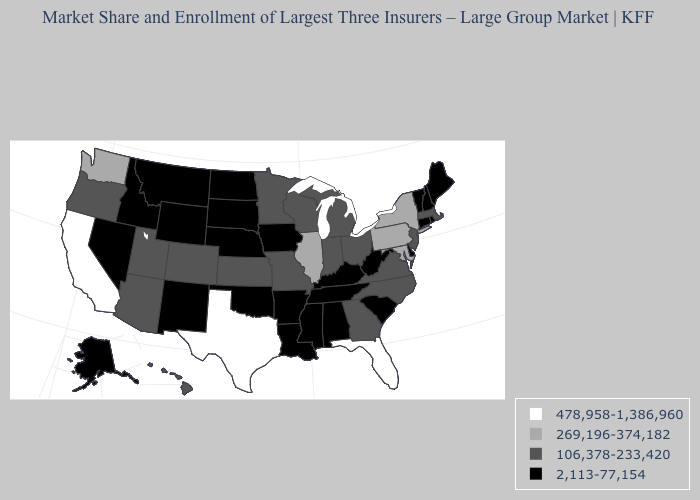What is the value of Wyoming?
Quick response, please. 2,113-77,154. Name the states that have a value in the range 106,378-233,420?
Keep it brief. Arizona, Colorado, Georgia, Hawaii, Indiana, Kansas, Massachusetts, Michigan, Minnesota, Missouri, New Jersey, North Carolina, Ohio, Oregon, Utah, Virginia, Wisconsin. What is the value of Arkansas?
Write a very short answer. 2,113-77,154. What is the value of Louisiana?
Concise answer only. 2,113-77,154. Does Texas have the highest value in the USA?
Be succinct. Yes. What is the lowest value in states that border Georgia?
Write a very short answer. 2,113-77,154. What is the highest value in states that border Illinois?
Quick response, please. 106,378-233,420. What is the value of New Mexico?
Quick response, please. 2,113-77,154. What is the value of Vermont?
Be succinct. 2,113-77,154. Is the legend a continuous bar?
Be succinct. No. Does Oregon have a higher value than New Jersey?
Be succinct. No. Does Rhode Island have the same value as Michigan?
Be succinct. No. Among the states that border Wyoming , which have the highest value?
Be succinct. Colorado, Utah. Which states hav the highest value in the Northeast?
Concise answer only. New York, Pennsylvania. What is the lowest value in the Northeast?
Short answer required. 2,113-77,154. 